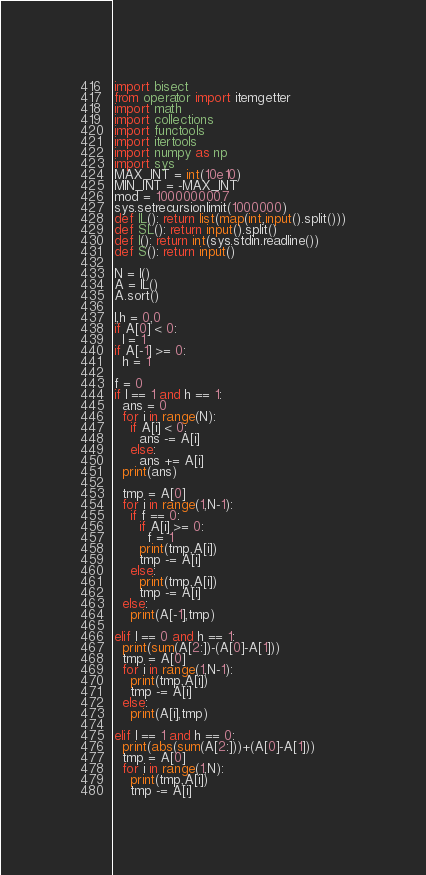<code> <loc_0><loc_0><loc_500><loc_500><_Python_>import bisect
from operator import itemgetter
import math
import collections
import functools
import itertools
import numpy as np
import sys
MAX_INT = int(10e10)
MIN_INT = -MAX_INT
mod = 1000000007
sys.setrecursionlimit(1000000)
def IL(): return list(map(int,input().split()))
def SL(): return input().split()
def I(): return int(sys.stdin.readline())
def S(): return input()

N = I()
A = IL()
A.sort()

l,h = 0,0
if A[0] < 0:
  l = 1
if A[-1] >= 0:
  h = 1

f = 0
if l == 1 and h == 1:
  ans = 0
  for i in range(N):
    if A[i] < 0:
      ans -= A[i]
    else:
      ans += A[i]
  print(ans)

  tmp = A[0]
  for i in range(1,N-1):
    if f == 0:
      if A[i] >= 0:
        f = 1
      print(tmp,A[i])
      tmp -= A[i]
    else:
      print(tmp,A[i])
      tmp -= A[i]
  else:
    print(A[-1],tmp)

elif l == 0 and h == 1:
  print(sum(A[2:])-(A[0]-A[1]))
  tmp = A[0]
  for i in range(1,N-1):
    print(tmp,A[i])
    tmp -= A[i]
  else:
    print(A[i],tmp)
    
elif l == 1 and h == 0:
  print(abs(sum(A[2:]))+(A[0]-A[1]))
  tmp = A[0]
  for i in range(1,N):
    print(tmp,A[i])
    tmp -= A[i]</code> 